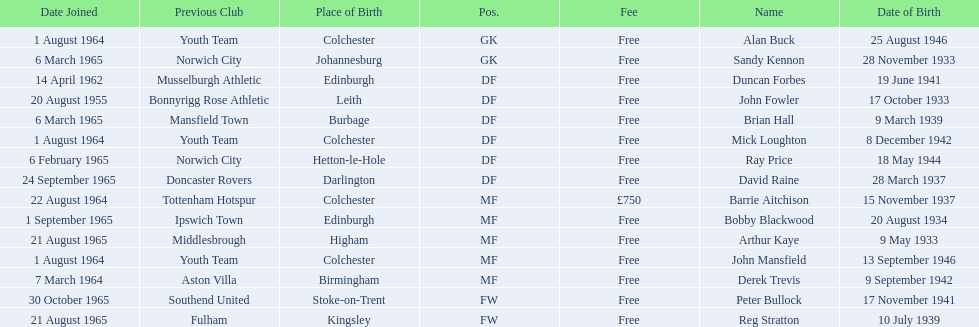Who are all the players? Alan Buck, Sandy Kennon, Duncan Forbes, John Fowler, Brian Hall, Mick Loughton, Ray Price, David Raine, Barrie Aitchison, Bobby Blackwood, Arthur Kaye, John Mansfield, Derek Trevis, Peter Bullock, Reg Stratton. What dates did the players join on? 1 August 1964, 6 March 1965, 14 April 1962, 20 August 1955, 6 March 1965, 1 August 1964, 6 February 1965, 24 September 1965, 22 August 1964, 1 September 1965, 21 August 1965, 1 August 1964, 7 March 1964, 30 October 1965, 21 August 1965. Who is the first player who joined? John Fowler. What is the date of the first person who joined? 20 August 1955. 